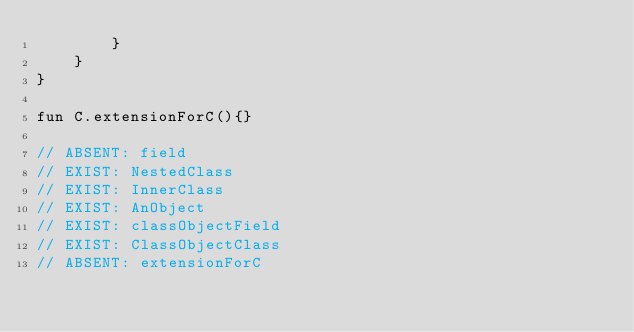Convert code to text. <code><loc_0><loc_0><loc_500><loc_500><_Kotlin_>        }
    }
}

fun C.extensionForC(){}

// ABSENT: field
// EXIST: NestedClass
// EXIST: InnerClass
// EXIST: AnObject
// EXIST: classObjectField
// EXIST: ClassObjectClass
// ABSENT: extensionForC
</code> 